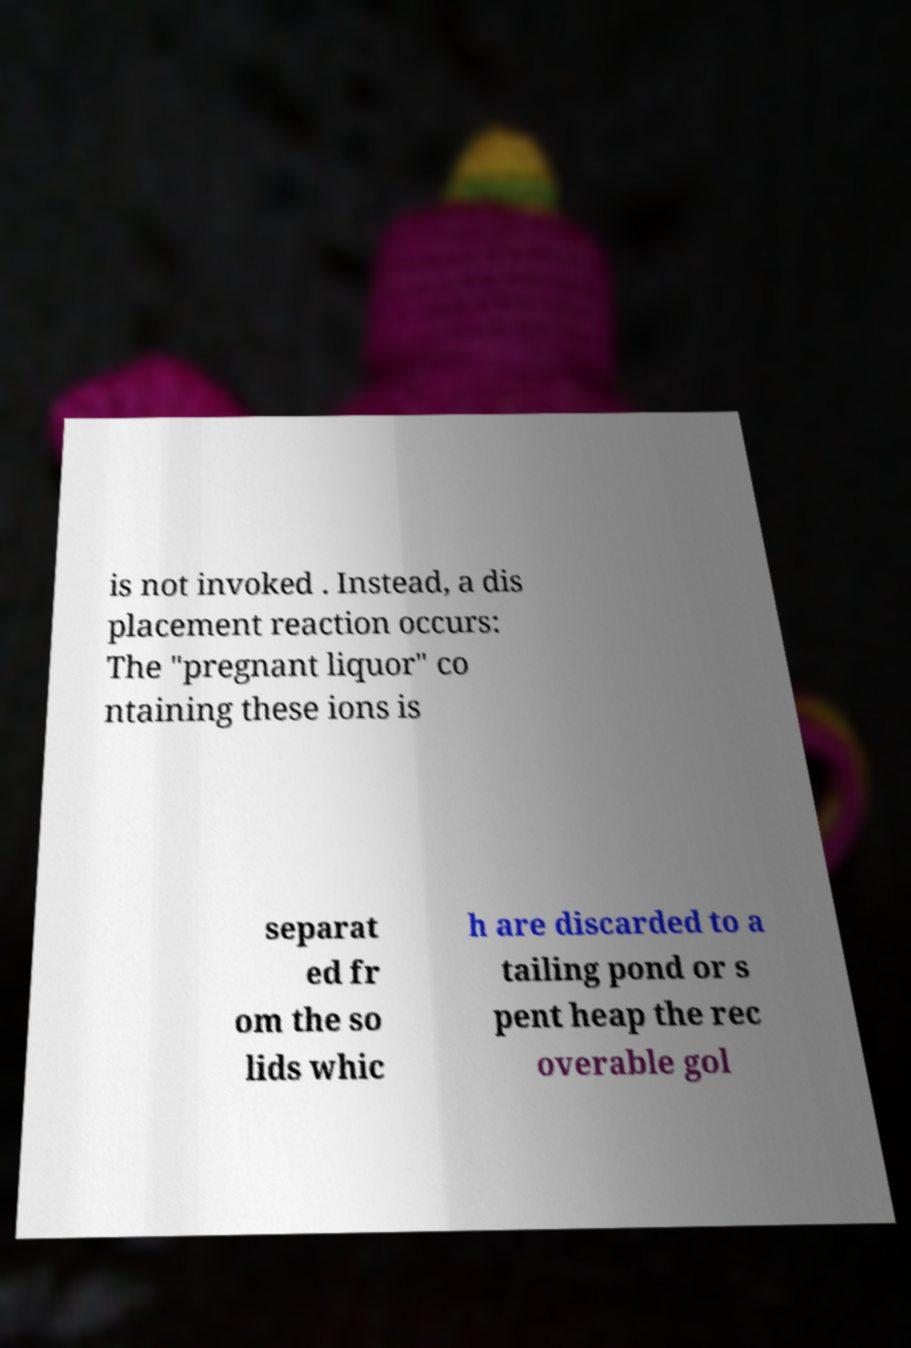Can you accurately transcribe the text from the provided image for me? is not invoked . Instead, a dis placement reaction occurs: The "pregnant liquor" co ntaining these ions is separat ed fr om the so lids whic h are discarded to a tailing pond or s pent heap the rec overable gol 